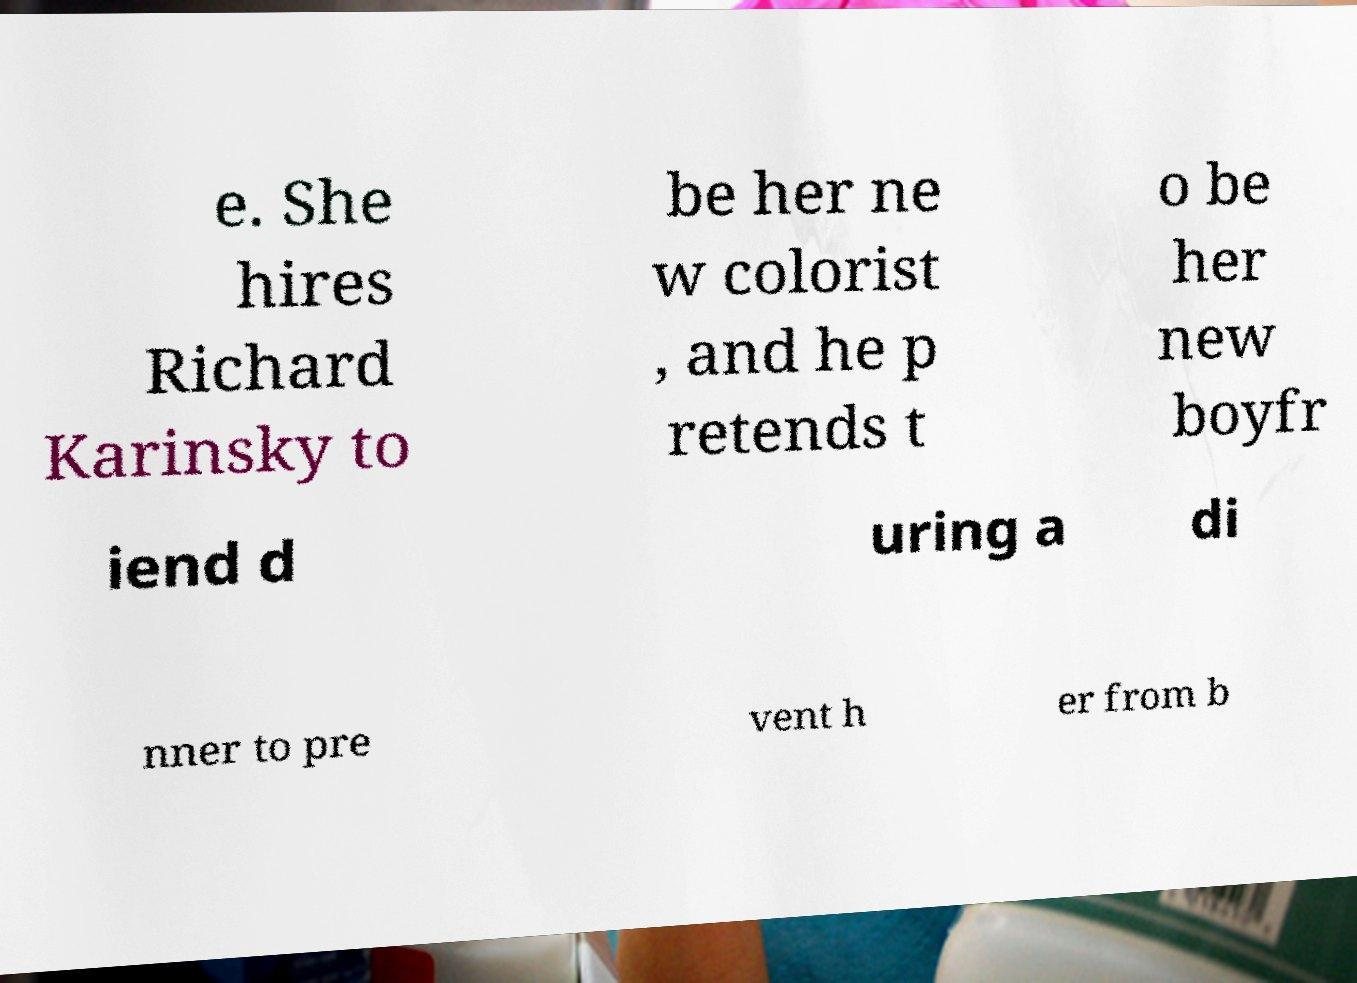Can you accurately transcribe the text from the provided image for me? e. She hires Richard Karinsky to be her ne w colorist , and he p retends t o be her new boyfr iend d uring a di nner to pre vent h er from b 